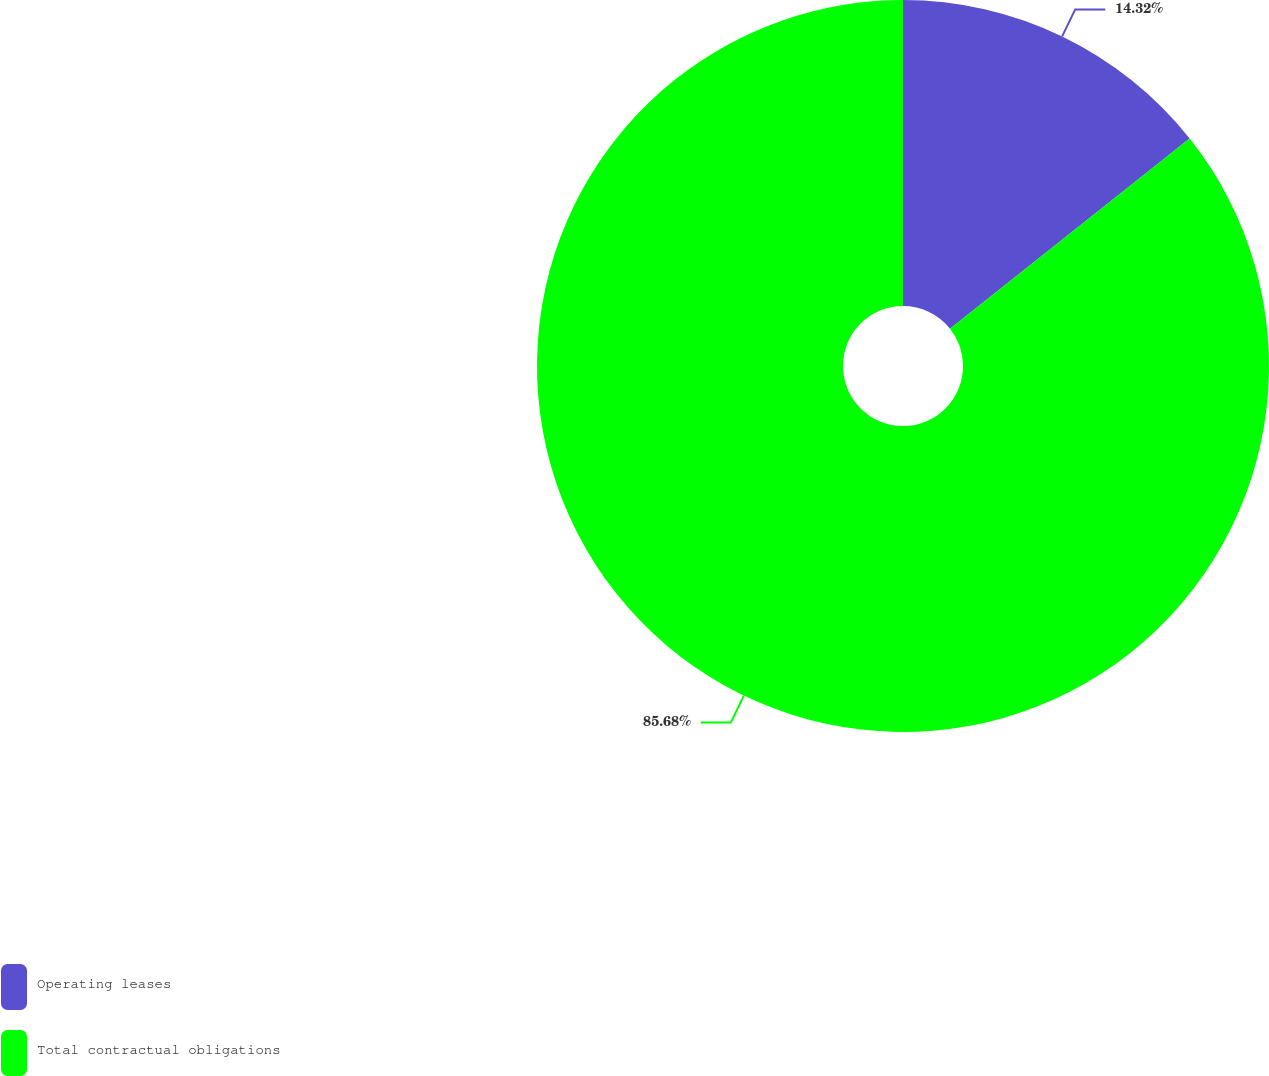<chart> <loc_0><loc_0><loc_500><loc_500><pie_chart><fcel>Operating leases<fcel>Total contractual obligations<nl><fcel>14.32%<fcel>85.68%<nl></chart> 